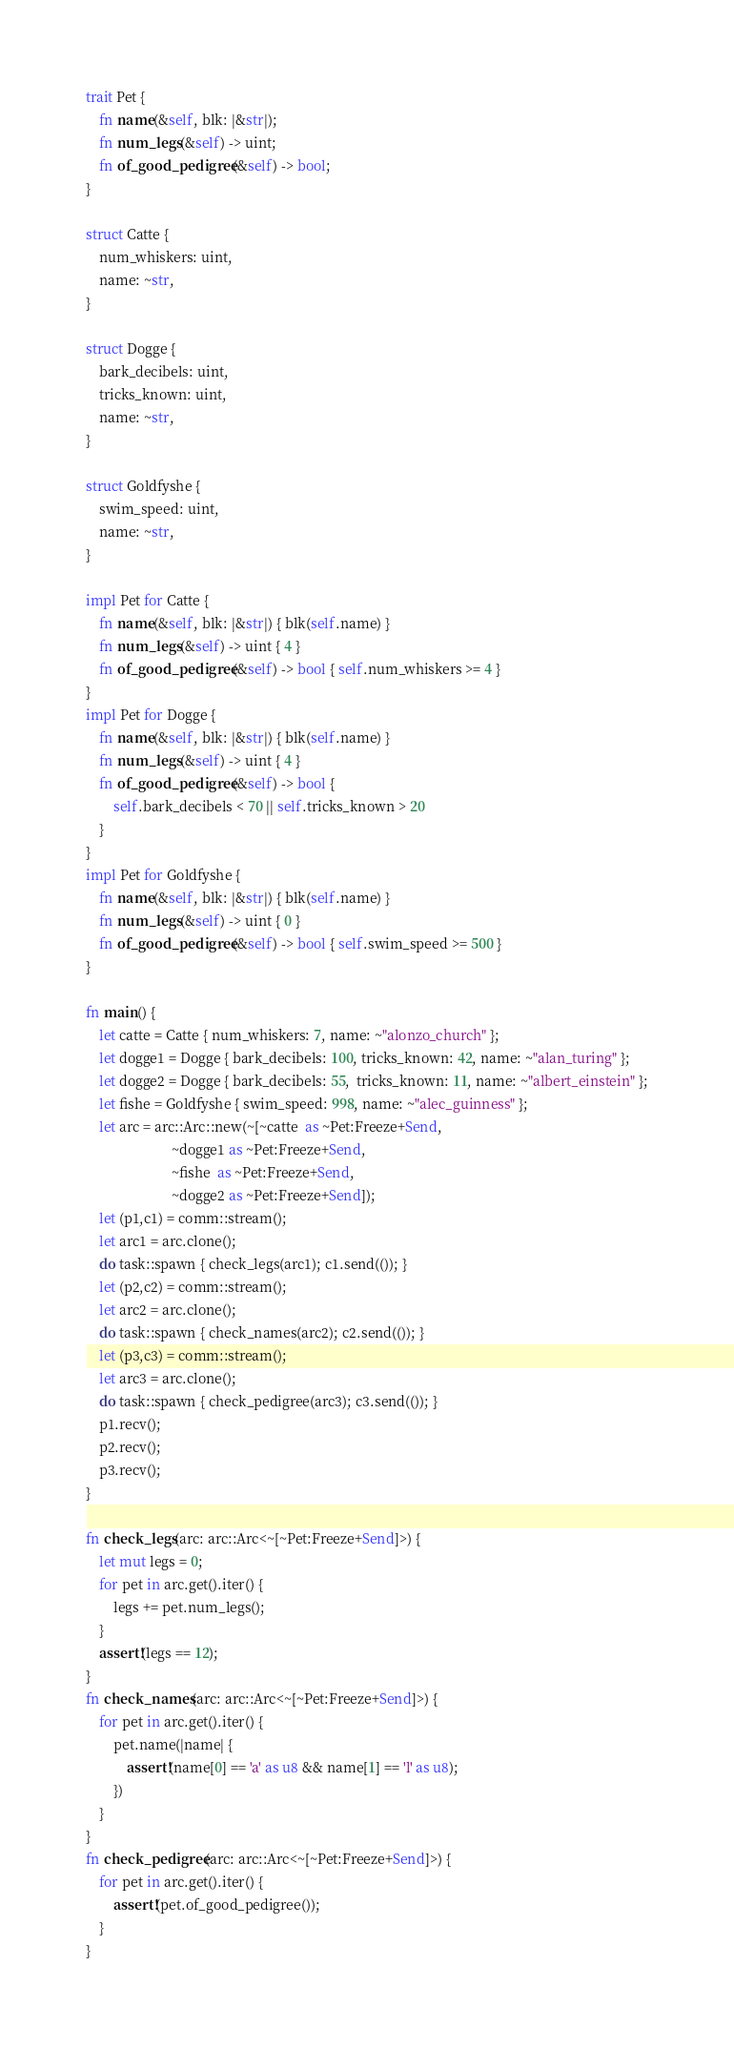<code> <loc_0><loc_0><loc_500><loc_500><_Rust_>
trait Pet {
    fn name(&self, blk: |&str|);
    fn num_legs(&self) -> uint;
    fn of_good_pedigree(&self) -> bool;
}

struct Catte {
    num_whiskers: uint,
    name: ~str,
}

struct Dogge {
    bark_decibels: uint,
    tricks_known: uint,
    name: ~str,
}

struct Goldfyshe {
    swim_speed: uint,
    name: ~str,
}

impl Pet for Catte {
    fn name(&self, blk: |&str|) { blk(self.name) }
    fn num_legs(&self) -> uint { 4 }
    fn of_good_pedigree(&self) -> bool { self.num_whiskers >= 4 }
}
impl Pet for Dogge {
    fn name(&self, blk: |&str|) { blk(self.name) }
    fn num_legs(&self) -> uint { 4 }
    fn of_good_pedigree(&self) -> bool {
        self.bark_decibels < 70 || self.tricks_known > 20
    }
}
impl Pet for Goldfyshe {
    fn name(&self, blk: |&str|) { blk(self.name) }
    fn num_legs(&self) -> uint { 0 }
    fn of_good_pedigree(&self) -> bool { self.swim_speed >= 500 }
}

fn main() {
    let catte = Catte { num_whiskers: 7, name: ~"alonzo_church" };
    let dogge1 = Dogge { bark_decibels: 100, tricks_known: 42, name: ~"alan_turing" };
    let dogge2 = Dogge { bark_decibels: 55,  tricks_known: 11, name: ~"albert_einstein" };
    let fishe = Goldfyshe { swim_speed: 998, name: ~"alec_guinness" };
    let arc = arc::Arc::new(~[~catte  as ~Pet:Freeze+Send,
                         ~dogge1 as ~Pet:Freeze+Send,
                         ~fishe  as ~Pet:Freeze+Send,
                         ~dogge2 as ~Pet:Freeze+Send]);
    let (p1,c1) = comm::stream();
    let arc1 = arc.clone();
    do task::spawn { check_legs(arc1); c1.send(()); }
    let (p2,c2) = comm::stream();
    let arc2 = arc.clone();
    do task::spawn { check_names(arc2); c2.send(()); }
    let (p3,c3) = comm::stream();
    let arc3 = arc.clone();
    do task::spawn { check_pedigree(arc3); c3.send(()); }
    p1.recv();
    p2.recv();
    p3.recv();
}

fn check_legs(arc: arc::Arc<~[~Pet:Freeze+Send]>) {
    let mut legs = 0;
    for pet in arc.get().iter() {
        legs += pet.num_legs();
    }
    assert!(legs == 12);
}
fn check_names(arc: arc::Arc<~[~Pet:Freeze+Send]>) {
    for pet in arc.get().iter() {
        pet.name(|name| {
            assert!(name[0] == 'a' as u8 && name[1] == 'l' as u8);
        })
    }
}
fn check_pedigree(arc: arc::Arc<~[~Pet:Freeze+Send]>) {
    for pet in arc.get().iter() {
        assert!(pet.of_good_pedigree());
    }
}
</code> 